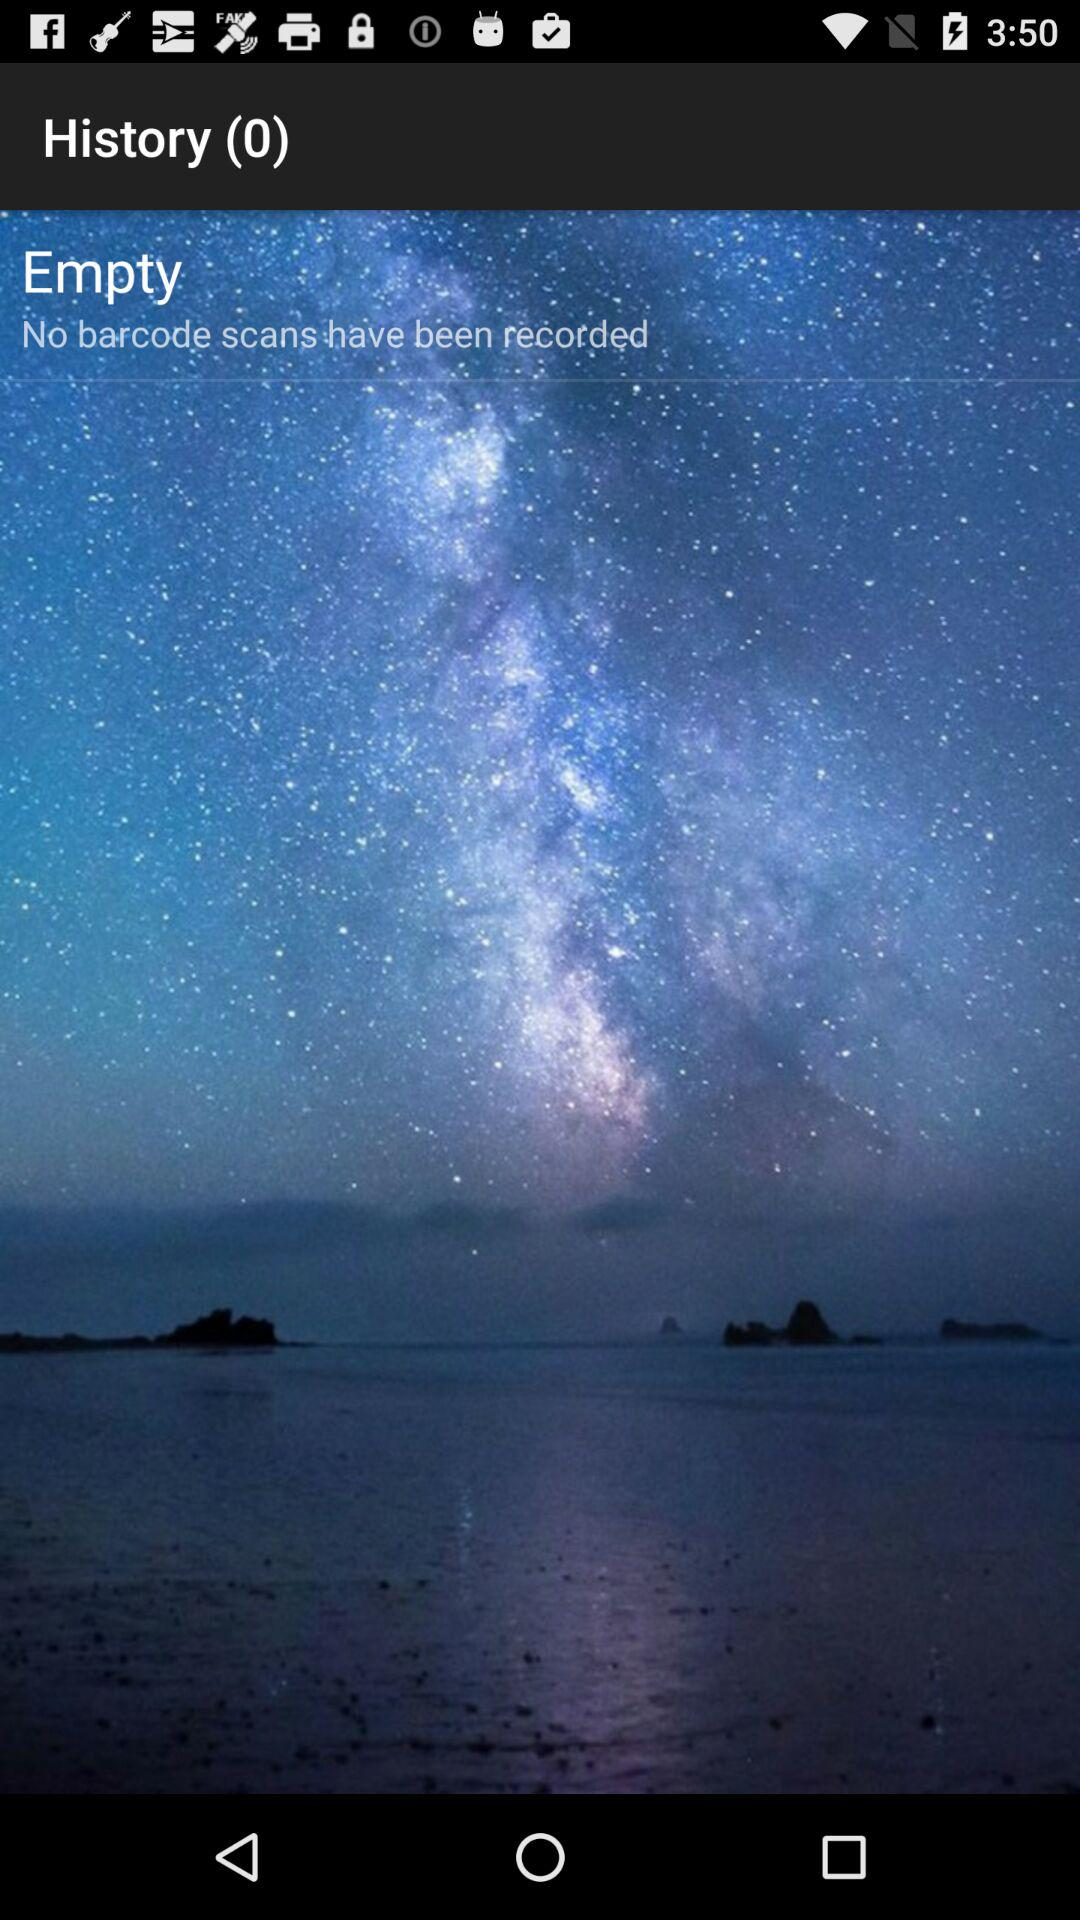How many notifications are available in "History"? There are 0 notifications available in "History". 